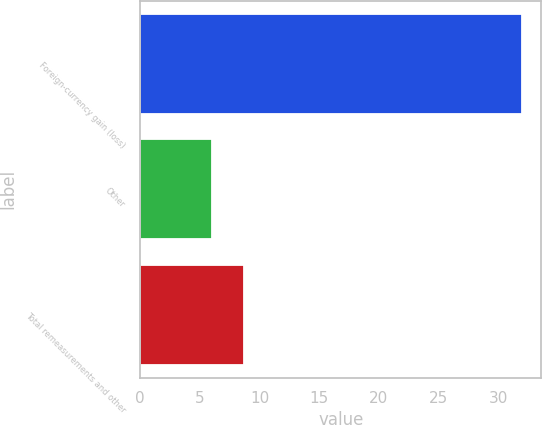Convert chart to OTSL. <chart><loc_0><loc_0><loc_500><loc_500><bar_chart><fcel>Foreign-currency gain (loss)<fcel>Other<fcel>Total remeasurements and other<nl><fcel>32<fcel>6<fcel>8.7<nl></chart> 